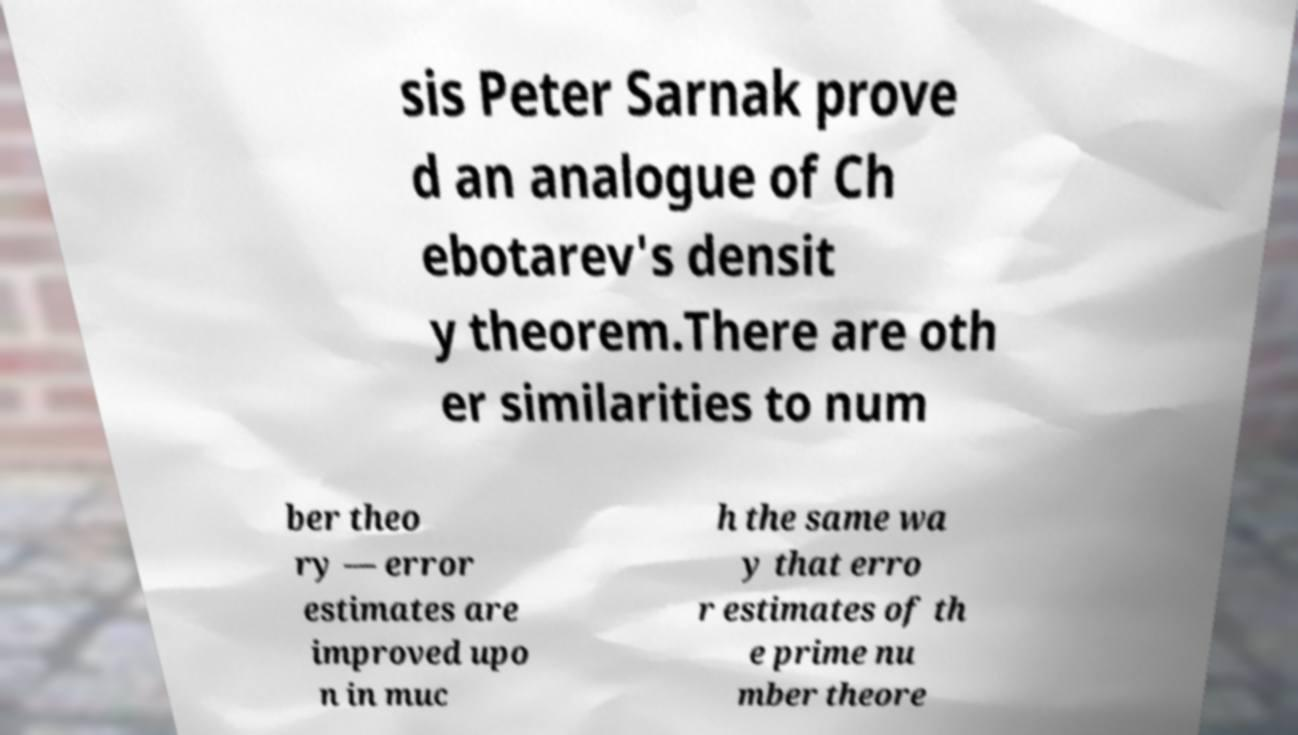Can you read and provide the text displayed in the image?This photo seems to have some interesting text. Can you extract and type it out for me? sis Peter Sarnak prove d an analogue of Ch ebotarev's densit y theorem.There are oth er similarities to num ber theo ry — error estimates are improved upo n in muc h the same wa y that erro r estimates of th e prime nu mber theore 